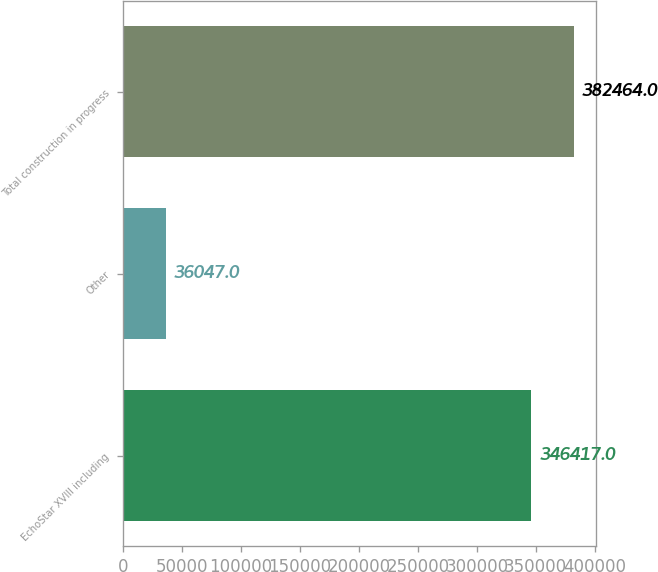Convert chart to OTSL. <chart><loc_0><loc_0><loc_500><loc_500><bar_chart><fcel>EchoStar XVIII including<fcel>Other<fcel>Total construction in progress<nl><fcel>346417<fcel>36047<fcel>382464<nl></chart> 